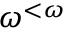<formula> <loc_0><loc_0><loc_500><loc_500>\omega ^ { < \omega }</formula> 